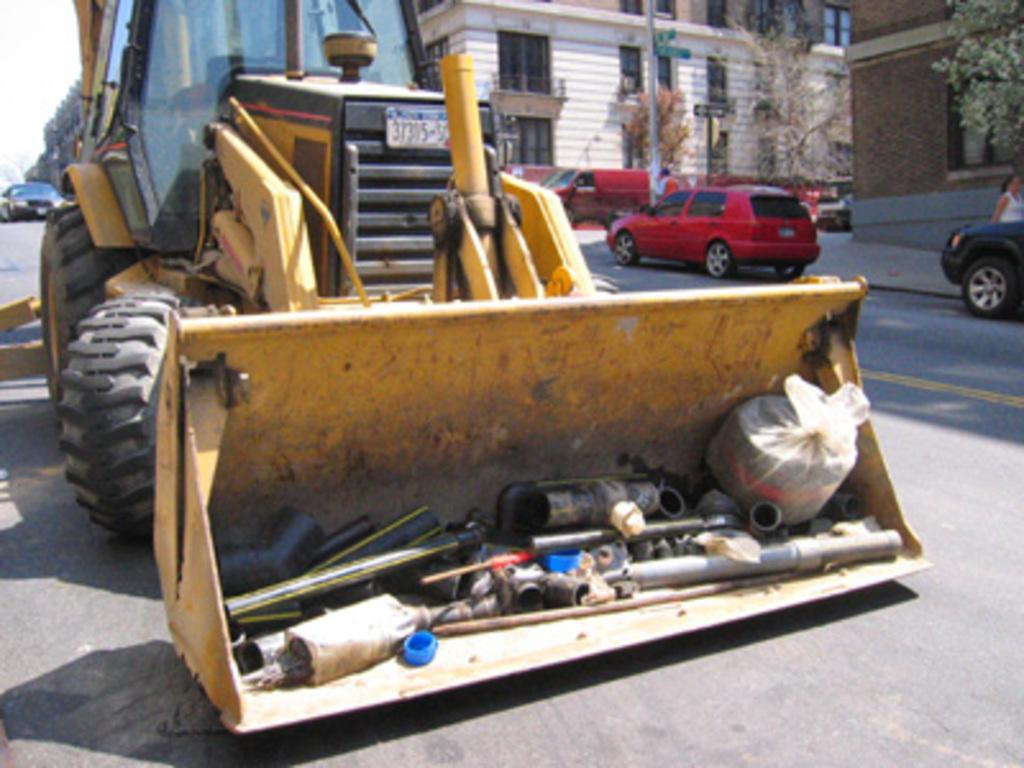Could you give a brief overview of what you see in this image? In the picture I can see vehicles, trees, buildings and some other things. In the background I can see the sky. 